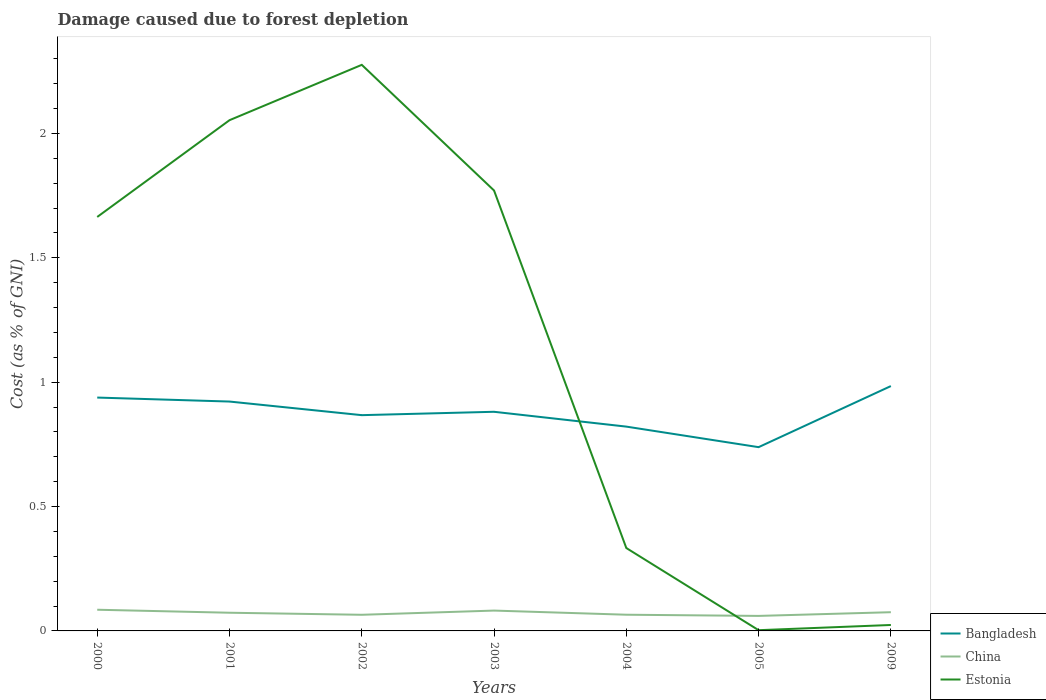How many different coloured lines are there?
Give a very brief answer. 3. Across all years, what is the maximum cost of damage caused due to forest depletion in China?
Offer a terse response. 0.06. In which year was the cost of damage caused due to forest depletion in China maximum?
Your answer should be very brief. 2005. What is the total cost of damage caused due to forest depletion in Bangladesh in the graph?
Provide a short and direct response. 0.18. What is the difference between the highest and the second highest cost of damage caused due to forest depletion in Bangladesh?
Keep it short and to the point. 0.25. Is the cost of damage caused due to forest depletion in China strictly greater than the cost of damage caused due to forest depletion in Estonia over the years?
Keep it short and to the point. No. How many years are there in the graph?
Offer a terse response. 7. What is the difference between two consecutive major ticks on the Y-axis?
Offer a very short reply. 0.5. Are the values on the major ticks of Y-axis written in scientific E-notation?
Give a very brief answer. No. How are the legend labels stacked?
Your answer should be compact. Vertical. What is the title of the graph?
Your answer should be very brief. Damage caused due to forest depletion. Does "South Africa" appear as one of the legend labels in the graph?
Offer a very short reply. No. What is the label or title of the Y-axis?
Provide a succinct answer. Cost (as % of GNI). What is the Cost (as % of GNI) of Bangladesh in 2000?
Provide a short and direct response. 0.94. What is the Cost (as % of GNI) in China in 2000?
Your response must be concise. 0.09. What is the Cost (as % of GNI) of Estonia in 2000?
Your answer should be compact. 1.66. What is the Cost (as % of GNI) of Bangladesh in 2001?
Provide a succinct answer. 0.92. What is the Cost (as % of GNI) in China in 2001?
Keep it short and to the point. 0.07. What is the Cost (as % of GNI) in Estonia in 2001?
Your answer should be very brief. 2.05. What is the Cost (as % of GNI) of Bangladesh in 2002?
Keep it short and to the point. 0.87. What is the Cost (as % of GNI) in China in 2002?
Keep it short and to the point. 0.06. What is the Cost (as % of GNI) in Estonia in 2002?
Provide a succinct answer. 2.28. What is the Cost (as % of GNI) of Bangladesh in 2003?
Keep it short and to the point. 0.88. What is the Cost (as % of GNI) of China in 2003?
Offer a very short reply. 0.08. What is the Cost (as % of GNI) of Estonia in 2003?
Make the answer very short. 1.77. What is the Cost (as % of GNI) of Bangladesh in 2004?
Your response must be concise. 0.82. What is the Cost (as % of GNI) of China in 2004?
Your answer should be compact. 0.07. What is the Cost (as % of GNI) of Estonia in 2004?
Ensure brevity in your answer.  0.33. What is the Cost (as % of GNI) in Bangladesh in 2005?
Offer a terse response. 0.74. What is the Cost (as % of GNI) of China in 2005?
Offer a terse response. 0.06. What is the Cost (as % of GNI) in Estonia in 2005?
Your response must be concise. 0. What is the Cost (as % of GNI) of Bangladesh in 2009?
Your response must be concise. 0.98. What is the Cost (as % of GNI) of China in 2009?
Your answer should be very brief. 0.08. What is the Cost (as % of GNI) of Estonia in 2009?
Provide a succinct answer. 0.02. Across all years, what is the maximum Cost (as % of GNI) of Bangladesh?
Give a very brief answer. 0.98. Across all years, what is the maximum Cost (as % of GNI) of China?
Provide a succinct answer. 0.09. Across all years, what is the maximum Cost (as % of GNI) in Estonia?
Keep it short and to the point. 2.28. Across all years, what is the minimum Cost (as % of GNI) in Bangladesh?
Offer a terse response. 0.74. Across all years, what is the minimum Cost (as % of GNI) in China?
Keep it short and to the point. 0.06. Across all years, what is the minimum Cost (as % of GNI) in Estonia?
Your answer should be very brief. 0. What is the total Cost (as % of GNI) of Bangladesh in the graph?
Offer a very short reply. 6.15. What is the total Cost (as % of GNI) of China in the graph?
Your answer should be very brief. 0.51. What is the total Cost (as % of GNI) of Estonia in the graph?
Keep it short and to the point. 8.12. What is the difference between the Cost (as % of GNI) in Bangladesh in 2000 and that in 2001?
Keep it short and to the point. 0.02. What is the difference between the Cost (as % of GNI) in China in 2000 and that in 2001?
Ensure brevity in your answer.  0.01. What is the difference between the Cost (as % of GNI) of Estonia in 2000 and that in 2001?
Offer a terse response. -0.39. What is the difference between the Cost (as % of GNI) in Bangladesh in 2000 and that in 2002?
Give a very brief answer. 0.07. What is the difference between the Cost (as % of GNI) of China in 2000 and that in 2002?
Provide a short and direct response. 0.02. What is the difference between the Cost (as % of GNI) in Estonia in 2000 and that in 2002?
Offer a very short reply. -0.61. What is the difference between the Cost (as % of GNI) in Bangladesh in 2000 and that in 2003?
Give a very brief answer. 0.06. What is the difference between the Cost (as % of GNI) in China in 2000 and that in 2003?
Give a very brief answer. 0. What is the difference between the Cost (as % of GNI) of Estonia in 2000 and that in 2003?
Make the answer very short. -0.11. What is the difference between the Cost (as % of GNI) in Bangladesh in 2000 and that in 2004?
Give a very brief answer. 0.12. What is the difference between the Cost (as % of GNI) in China in 2000 and that in 2004?
Make the answer very short. 0.02. What is the difference between the Cost (as % of GNI) in Estonia in 2000 and that in 2004?
Your answer should be very brief. 1.33. What is the difference between the Cost (as % of GNI) of Bangladesh in 2000 and that in 2005?
Keep it short and to the point. 0.2. What is the difference between the Cost (as % of GNI) of China in 2000 and that in 2005?
Keep it short and to the point. 0.02. What is the difference between the Cost (as % of GNI) of Estonia in 2000 and that in 2005?
Your response must be concise. 1.66. What is the difference between the Cost (as % of GNI) in Bangladesh in 2000 and that in 2009?
Your response must be concise. -0.05. What is the difference between the Cost (as % of GNI) of China in 2000 and that in 2009?
Give a very brief answer. 0.01. What is the difference between the Cost (as % of GNI) in Estonia in 2000 and that in 2009?
Offer a very short reply. 1.64. What is the difference between the Cost (as % of GNI) of Bangladesh in 2001 and that in 2002?
Make the answer very short. 0.05. What is the difference between the Cost (as % of GNI) in China in 2001 and that in 2002?
Provide a succinct answer. 0.01. What is the difference between the Cost (as % of GNI) of Estonia in 2001 and that in 2002?
Provide a short and direct response. -0.22. What is the difference between the Cost (as % of GNI) of Bangladesh in 2001 and that in 2003?
Keep it short and to the point. 0.04. What is the difference between the Cost (as % of GNI) of China in 2001 and that in 2003?
Make the answer very short. -0.01. What is the difference between the Cost (as % of GNI) in Estonia in 2001 and that in 2003?
Your answer should be very brief. 0.28. What is the difference between the Cost (as % of GNI) in Bangladesh in 2001 and that in 2004?
Provide a succinct answer. 0.1. What is the difference between the Cost (as % of GNI) in China in 2001 and that in 2004?
Your response must be concise. 0.01. What is the difference between the Cost (as % of GNI) of Estonia in 2001 and that in 2004?
Provide a short and direct response. 1.72. What is the difference between the Cost (as % of GNI) in Bangladesh in 2001 and that in 2005?
Keep it short and to the point. 0.18. What is the difference between the Cost (as % of GNI) in China in 2001 and that in 2005?
Give a very brief answer. 0.01. What is the difference between the Cost (as % of GNI) in Estonia in 2001 and that in 2005?
Your answer should be very brief. 2.05. What is the difference between the Cost (as % of GNI) in Bangladesh in 2001 and that in 2009?
Offer a terse response. -0.06. What is the difference between the Cost (as % of GNI) of China in 2001 and that in 2009?
Keep it short and to the point. -0. What is the difference between the Cost (as % of GNI) of Estonia in 2001 and that in 2009?
Keep it short and to the point. 2.03. What is the difference between the Cost (as % of GNI) of Bangladesh in 2002 and that in 2003?
Offer a very short reply. -0.01. What is the difference between the Cost (as % of GNI) in China in 2002 and that in 2003?
Your response must be concise. -0.02. What is the difference between the Cost (as % of GNI) of Estonia in 2002 and that in 2003?
Provide a short and direct response. 0.51. What is the difference between the Cost (as % of GNI) in Bangladesh in 2002 and that in 2004?
Your answer should be very brief. 0.05. What is the difference between the Cost (as % of GNI) in China in 2002 and that in 2004?
Your response must be concise. -0. What is the difference between the Cost (as % of GNI) of Estonia in 2002 and that in 2004?
Offer a very short reply. 1.94. What is the difference between the Cost (as % of GNI) in Bangladesh in 2002 and that in 2005?
Your answer should be compact. 0.13. What is the difference between the Cost (as % of GNI) of China in 2002 and that in 2005?
Give a very brief answer. 0. What is the difference between the Cost (as % of GNI) in Estonia in 2002 and that in 2005?
Give a very brief answer. 2.27. What is the difference between the Cost (as % of GNI) in Bangladesh in 2002 and that in 2009?
Make the answer very short. -0.12. What is the difference between the Cost (as % of GNI) in China in 2002 and that in 2009?
Ensure brevity in your answer.  -0.01. What is the difference between the Cost (as % of GNI) of Estonia in 2002 and that in 2009?
Provide a succinct answer. 2.25. What is the difference between the Cost (as % of GNI) of Bangladesh in 2003 and that in 2004?
Provide a succinct answer. 0.06. What is the difference between the Cost (as % of GNI) in China in 2003 and that in 2004?
Your response must be concise. 0.02. What is the difference between the Cost (as % of GNI) in Estonia in 2003 and that in 2004?
Your answer should be compact. 1.44. What is the difference between the Cost (as % of GNI) of Bangladesh in 2003 and that in 2005?
Your answer should be compact. 0.14. What is the difference between the Cost (as % of GNI) of China in 2003 and that in 2005?
Ensure brevity in your answer.  0.02. What is the difference between the Cost (as % of GNI) in Estonia in 2003 and that in 2005?
Keep it short and to the point. 1.77. What is the difference between the Cost (as % of GNI) of Bangladesh in 2003 and that in 2009?
Your response must be concise. -0.1. What is the difference between the Cost (as % of GNI) in China in 2003 and that in 2009?
Your answer should be compact. 0.01. What is the difference between the Cost (as % of GNI) in Estonia in 2003 and that in 2009?
Provide a short and direct response. 1.75. What is the difference between the Cost (as % of GNI) of Bangladesh in 2004 and that in 2005?
Your answer should be compact. 0.08. What is the difference between the Cost (as % of GNI) in China in 2004 and that in 2005?
Your answer should be compact. 0. What is the difference between the Cost (as % of GNI) of Estonia in 2004 and that in 2005?
Your answer should be compact. 0.33. What is the difference between the Cost (as % of GNI) of Bangladesh in 2004 and that in 2009?
Your answer should be very brief. -0.16. What is the difference between the Cost (as % of GNI) in China in 2004 and that in 2009?
Offer a very short reply. -0.01. What is the difference between the Cost (as % of GNI) in Estonia in 2004 and that in 2009?
Give a very brief answer. 0.31. What is the difference between the Cost (as % of GNI) in Bangladesh in 2005 and that in 2009?
Your response must be concise. -0.25. What is the difference between the Cost (as % of GNI) of China in 2005 and that in 2009?
Provide a succinct answer. -0.01. What is the difference between the Cost (as % of GNI) of Estonia in 2005 and that in 2009?
Provide a short and direct response. -0.02. What is the difference between the Cost (as % of GNI) in Bangladesh in 2000 and the Cost (as % of GNI) in China in 2001?
Make the answer very short. 0.87. What is the difference between the Cost (as % of GNI) of Bangladesh in 2000 and the Cost (as % of GNI) of Estonia in 2001?
Your answer should be compact. -1.12. What is the difference between the Cost (as % of GNI) of China in 2000 and the Cost (as % of GNI) of Estonia in 2001?
Make the answer very short. -1.97. What is the difference between the Cost (as % of GNI) in Bangladesh in 2000 and the Cost (as % of GNI) in China in 2002?
Give a very brief answer. 0.87. What is the difference between the Cost (as % of GNI) of Bangladesh in 2000 and the Cost (as % of GNI) of Estonia in 2002?
Your answer should be compact. -1.34. What is the difference between the Cost (as % of GNI) in China in 2000 and the Cost (as % of GNI) in Estonia in 2002?
Make the answer very short. -2.19. What is the difference between the Cost (as % of GNI) of Bangladesh in 2000 and the Cost (as % of GNI) of China in 2003?
Offer a very short reply. 0.86. What is the difference between the Cost (as % of GNI) of Bangladesh in 2000 and the Cost (as % of GNI) of Estonia in 2003?
Your answer should be compact. -0.83. What is the difference between the Cost (as % of GNI) in China in 2000 and the Cost (as % of GNI) in Estonia in 2003?
Offer a terse response. -1.69. What is the difference between the Cost (as % of GNI) of Bangladesh in 2000 and the Cost (as % of GNI) of China in 2004?
Provide a succinct answer. 0.87. What is the difference between the Cost (as % of GNI) of Bangladesh in 2000 and the Cost (as % of GNI) of Estonia in 2004?
Ensure brevity in your answer.  0.6. What is the difference between the Cost (as % of GNI) of China in 2000 and the Cost (as % of GNI) of Estonia in 2004?
Provide a short and direct response. -0.25. What is the difference between the Cost (as % of GNI) of Bangladesh in 2000 and the Cost (as % of GNI) of China in 2005?
Your answer should be compact. 0.88. What is the difference between the Cost (as % of GNI) of Bangladesh in 2000 and the Cost (as % of GNI) of Estonia in 2005?
Your response must be concise. 0.94. What is the difference between the Cost (as % of GNI) in China in 2000 and the Cost (as % of GNI) in Estonia in 2005?
Provide a succinct answer. 0.08. What is the difference between the Cost (as % of GNI) of Bangladesh in 2000 and the Cost (as % of GNI) of China in 2009?
Your response must be concise. 0.86. What is the difference between the Cost (as % of GNI) of Bangladesh in 2000 and the Cost (as % of GNI) of Estonia in 2009?
Your answer should be compact. 0.91. What is the difference between the Cost (as % of GNI) of China in 2000 and the Cost (as % of GNI) of Estonia in 2009?
Provide a short and direct response. 0.06. What is the difference between the Cost (as % of GNI) in Bangladesh in 2001 and the Cost (as % of GNI) in China in 2002?
Keep it short and to the point. 0.86. What is the difference between the Cost (as % of GNI) of Bangladesh in 2001 and the Cost (as % of GNI) of Estonia in 2002?
Provide a short and direct response. -1.35. What is the difference between the Cost (as % of GNI) in China in 2001 and the Cost (as % of GNI) in Estonia in 2002?
Keep it short and to the point. -2.2. What is the difference between the Cost (as % of GNI) of Bangladesh in 2001 and the Cost (as % of GNI) of China in 2003?
Ensure brevity in your answer.  0.84. What is the difference between the Cost (as % of GNI) in Bangladesh in 2001 and the Cost (as % of GNI) in Estonia in 2003?
Offer a very short reply. -0.85. What is the difference between the Cost (as % of GNI) of China in 2001 and the Cost (as % of GNI) of Estonia in 2003?
Provide a succinct answer. -1.7. What is the difference between the Cost (as % of GNI) in Bangladesh in 2001 and the Cost (as % of GNI) in China in 2004?
Your answer should be compact. 0.86. What is the difference between the Cost (as % of GNI) in Bangladesh in 2001 and the Cost (as % of GNI) in Estonia in 2004?
Ensure brevity in your answer.  0.59. What is the difference between the Cost (as % of GNI) of China in 2001 and the Cost (as % of GNI) of Estonia in 2004?
Offer a very short reply. -0.26. What is the difference between the Cost (as % of GNI) in Bangladesh in 2001 and the Cost (as % of GNI) in China in 2005?
Give a very brief answer. 0.86. What is the difference between the Cost (as % of GNI) in Bangladesh in 2001 and the Cost (as % of GNI) in Estonia in 2005?
Your response must be concise. 0.92. What is the difference between the Cost (as % of GNI) in China in 2001 and the Cost (as % of GNI) in Estonia in 2005?
Provide a succinct answer. 0.07. What is the difference between the Cost (as % of GNI) in Bangladesh in 2001 and the Cost (as % of GNI) in China in 2009?
Your answer should be very brief. 0.85. What is the difference between the Cost (as % of GNI) of Bangladesh in 2001 and the Cost (as % of GNI) of Estonia in 2009?
Provide a short and direct response. 0.9. What is the difference between the Cost (as % of GNI) of China in 2001 and the Cost (as % of GNI) of Estonia in 2009?
Your response must be concise. 0.05. What is the difference between the Cost (as % of GNI) in Bangladesh in 2002 and the Cost (as % of GNI) in China in 2003?
Your answer should be very brief. 0.79. What is the difference between the Cost (as % of GNI) in Bangladesh in 2002 and the Cost (as % of GNI) in Estonia in 2003?
Provide a succinct answer. -0.9. What is the difference between the Cost (as % of GNI) of China in 2002 and the Cost (as % of GNI) of Estonia in 2003?
Offer a very short reply. -1.71. What is the difference between the Cost (as % of GNI) of Bangladesh in 2002 and the Cost (as % of GNI) of China in 2004?
Offer a terse response. 0.8. What is the difference between the Cost (as % of GNI) of Bangladesh in 2002 and the Cost (as % of GNI) of Estonia in 2004?
Provide a succinct answer. 0.53. What is the difference between the Cost (as % of GNI) of China in 2002 and the Cost (as % of GNI) of Estonia in 2004?
Your answer should be very brief. -0.27. What is the difference between the Cost (as % of GNI) of Bangladesh in 2002 and the Cost (as % of GNI) of China in 2005?
Make the answer very short. 0.81. What is the difference between the Cost (as % of GNI) in Bangladesh in 2002 and the Cost (as % of GNI) in Estonia in 2005?
Offer a very short reply. 0.86. What is the difference between the Cost (as % of GNI) in China in 2002 and the Cost (as % of GNI) in Estonia in 2005?
Provide a short and direct response. 0.06. What is the difference between the Cost (as % of GNI) of Bangladesh in 2002 and the Cost (as % of GNI) of China in 2009?
Keep it short and to the point. 0.79. What is the difference between the Cost (as % of GNI) of Bangladesh in 2002 and the Cost (as % of GNI) of Estonia in 2009?
Give a very brief answer. 0.84. What is the difference between the Cost (as % of GNI) of China in 2002 and the Cost (as % of GNI) of Estonia in 2009?
Offer a very short reply. 0.04. What is the difference between the Cost (as % of GNI) of Bangladesh in 2003 and the Cost (as % of GNI) of China in 2004?
Provide a succinct answer. 0.82. What is the difference between the Cost (as % of GNI) of Bangladesh in 2003 and the Cost (as % of GNI) of Estonia in 2004?
Ensure brevity in your answer.  0.55. What is the difference between the Cost (as % of GNI) in China in 2003 and the Cost (as % of GNI) in Estonia in 2004?
Offer a very short reply. -0.25. What is the difference between the Cost (as % of GNI) in Bangladesh in 2003 and the Cost (as % of GNI) in China in 2005?
Your answer should be very brief. 0.82. What is the difference between the Cost (as % of GNI) of Bangladesh in 2003 and the Cost (as % of GNI) of Estonia in 2005?
Keep it short and to the point. 0.88. What is the difference between the Cost (as % of GNI) of China in 2003 and the Cost (as % of GNI) of Estonia in 2005?
Give a very brief answer. 0.08. What is the difference between the Cost (as % of GNI) of Bangladesh in 2003 and the Cost (as % of GNI) of China in 2009?
Ensure brevity in your answer.  0.81. What is the difference between the Cost (as % of GNI) in Bangladesh in 2003 and the Cost (as % of GNI) in Estonia in 2009?
Your answer should be very brief. 0.86. What is the difference between the Cost (as % of GNI) in China in 2003 and the Cost (as % of GNI) in Estonia in 2009?
Make the answer very short. 0.06. What is the difference between the Cost (as % of GNI) of Bangladesh in 2004 and the Cost (as % of GNI) of China in 2005?
Provide a short and direct response. 0.76. What is the difference between the Cost (as % of GNI) in Bangladesh in 2004 and the Cost (as % of GNI) in Estonia in 2005?
Offer a very short reply. 0.82. What is the difference between the Cost (as % of GNI) of China in 2004 and the Cost (as % of GNI) of Estonia in 2005?
Your answer should be very brief. 0.06. What is the difference between the Cost (as % of GNI) in Bangladesh in 2004 and the Cost (as % of GNI) in China in 2009?
Keep it short and to the point. 0.75. What is the difference between the Cost (as % of GNI) in Bangladesh in 2004 and the Cost (as % of GNI) in Estonia in 2009?
Your answer should be very brief. 0.8. What is the difference between the Cost (as % of GNI) of China in 2004 and the Cost (as % of GNI) of Estonia in 2009?
Keep it short and to the point. 0.04. What is the difference between the Cost (as % of GNI) in Bangladesh in 2005 and the Cost (as % of GNI) in China in 2009?
Keep it short and to the point. 0.66. What is the difference between the Cost (as % of GNI) in Bangladesh in 2005 and the Cost (as % of GNI) in Estonia in 2009?
Make the answer very short. 0.71. What is the difference between the Cost (as % of GNI) of China in 2005 and the Cost (as % of GNI) of Estonia in 2009?
Provide a succinct answer. 0.04. What is the average Cost (as % of GNI) of Bangladesh per year?
Your response must be concise. 0.88. What is the average Cost (as % of GNI) of China per year?
Ensure brevity in your answer.  0.07. What is the average Cost (as % of GNI) of Estonia per year?
Give a very brief answer. 1.16. In the year 2000, what is the difference between the Cost (as % of GNI) in Bangladesh and Cost (as % of GNI) in China?
Offer a terse response. 0.85. In the year 2000, what is the difference between the Cost (as % of GNI) in Bangladesh and Cost (as % of GNI) in Estonia?
Offer a very short reply. -0.73. In the year 2000, what is the difference between the Cost (as % of GNI) of China and Cost (as % of GNI) of Estonia?
Make the answer very short. -1.58. In the year 2001, what is the difference between the Cost (as % of GNI) of Bangladesh and Cost (as % of GNI) of China?
Ensure brevity in your answer.  0.85. In the year 2001, what is the difference between the Cost (as % of GNI) in Bangladesh and Cost (as % of GNI) in Estonia?
Give a very brief answer. -1.13. In the year 2001, what is the difference between the Cost (as % of GNI) of China and Cost (as % of GNI) of Estonia?
Give a very brief answer. -1.98. In the year 2002, what is the difference between the Cost (as % of GNI) of Bangladesh and Cost (as % of GNI) of China?
Your response must be concise. 0.8. In the year 2002, what is the difference between the Cost (as % of GNI) in Bangladesh and Cost (as % of GNI) in Estonia?
Your answer should be very brief. -1.41. In the year 2002, what is the difference between the Cost (as % of GNI) of China and Cost (as % of GNI) of Estonia?
Your answer should be very brief. -2.21. In the year 2003, what is the difference between the Cost (as % of GNI) in Bangladesh and Cost (as % of GNI) in China?
Your answer should be very brief. 0.8. In the year 2003, what is the difference between the Cost (as % of GNI) in Bangladesh and Cost (as % of GNI) in Estonia?
Provide a short and direct response. -0.89. In the year 2003, what is the difference between the Cost (as % of GNI) of China and Cost (as % of GNI) of Estonia?
Your answer should be very brief. -1.69. In the year 2004, what is the difference between the Cost (as % of GNI) of Bangladesh and Cost (as % of GNI) of China?
Offer a terse response. 0.76. In the year 2004, what is the difference between the Cost (as % of GNI) of Bangladesh and Cost (as % of GNI) of Estonia?
Your answer should be compact. 0.49. In the year 2004, what is the difference between the Cost (as % of GNI) of China and Cost (as % of GNI) of Estonia?
Provide a succinct answer. -0.27. In the year 2005, what is the difference between the Cost (as % of GNI) of Bangladesh and Cost (as % of GNI) of China?
Provide a short and direct response. 0.68. In the year 2005, what is the difference between the Cost (as % of GNI) in Bangladesh and Cost (as % of GNI) in Estonia?
Keep it short and to the point. 0.74. In the year 2005, what is the difference between the Cost (as % of GNI) of China and Cost (as % of GNI) of Estonia?
Keep it short and to the point. 0.06. In the year 2009, what is the difference between the Cost (as % of GNI) of Bangladesh and Cost (as % of GNI) of China?
Make the answer very short. 0.91. In the year 2009, what is the difference between the Cost (as % of GNI) of Bangladesh and Cost (as % of GNI) of Estonia?
Make the answer very short. 0.96. In the year 2009, what is the difference between the Cost (as % of GNI) of China and Cost (as % of GNI) of Estonia?
Offer a very short reply. 0.05. What is the ratio of the Cost (as % of GNI) in Bangladesh in 2000 to that in 2001?
Make the answer very short. 1.02. What is the ratio of the Cost (as % of GNI) of China in 2000 to that in 2001?
Your answer should be very brief. 1.17. What is the ratio of the Cost (as % of GNI) of Estonia in 2000 to that in 2001?
Provide a short and direct response. 0.81. What is the ratio of the Cost (as % of GNI) of Bangladesh in 2000 to that in 2002?
Provide a short and direct response. 1.08. What is the ratio of the Cost (as % of GNI) of China in 2000 to that in 2002?
Offer a terse response. 1.31. What is the ratio of the Cost (as % of GNI) in Estonia in 2000 to that in 2002?
Provide a short and direct response. 0.73. What is the ratio of the Cost (as % of GNI) of Bangladesh in 2000 to that in 2003?
Your answer should be compact. 1.06. What is the ratio of the Cost (as % of GNI) of China in 2000 to that in 2003?
Give a very brief answer. 1.04. What is the ratio of the Cost (as % of GNI) of Estonia in 2000 to that in 2003?
Give a very brief answer. 0.94. What is the ratio of the Cost (as % of GNI) in Bangladesh in 2000 to that in 2004?
Offer a terse response. 1.14. What is the ratio of the Cost (as % of GNI) of China in 2000 to that in 2004?
Give a very brief answer. 1.31. What is the ratio of the Cost (as % of GNI) of Estonia in 2000 to that in 2004?
Offer a terse response. 4.99. What is the ratio of the Cost (as % of GNI) of Bangladesh in 2000 to that in 2005?
Provide a short and direct response. 1.27. What is the ratio of the Cost (as % of GNI) in China in 2000 to that in 2005?
Give a very brief answer. 1.41. What is the ratio of the Cost (as % of GNI) in Estonia in 2000 to that in 2005?
Your response must be concise. 559.5. What is the ratio of the Cost (as % of GNI) in Bangladesh in 2000 to that in 2009?
Offer a very short reply. 0.95. What is the ratio of the Cost (as % of GNI) in China in 2000 to that in 2009?
Offer a terse response. 1.13. What is the ratio of the Cost (as % of GNI) in Estonia in 2000 to that in 2009?
Your answer should be very brief. 69.63. What is the ratio of the Cost (as % of GNI) in Bangladesh in 2001 to that in 2002?
Give a very brief answer. 1.06. What is the ratio of the Cost (as % of GNI) of China in 2001 to that in 2002?
Provide a short and direct response. 1.13. What is the ratio of the Cost (as % of GNI) in Estonia in 2001 to that in 2002?
Offer a terse response. 0.9. What is the ratio of the Cost (as % of GNI) in Bangladesh in 2001 to that in 2003?
Offer a terse response. 1.05. What is the ratio of the Cost (as % of GNI) of China in 2001 to that in 2003?
Offer a terse response. 0.89. What is the ratio of the Cost (as % of GNI) of Estonia in 2001 to that in 2003?
Provide a short and direct response. 1.16. What is the ratio of the Cost (as % of GNI) of Bangladesh in 2001 to that in 2004?
Provide a succinct answer. 1.12. What is the ratio of the Cost (as % of GNI) of China in 2001 to that in 2004?
Provide a succinct answer. 1.12. What is the ratio of the Cost (as % of GNI) in Estonia in 2001 to that in 2004?
Make the answer very short. 6.16. What is the ratio of the Cost (as % of GNI) of Bangladesh in 2001 to that in 2005?
Make the answer very short. 1.25. What is the ratio of the Cost (as % of GNI) of China in 2001 to that in 2005?
Keep it short and to the point. 1.21. What is the ratio of the Cost (as % of GNI) of Estonia in 2001 to that in 2005?
Keep it short and to the point. 690.29. What is the ratio of the Cost (as % of GNI) in Bangladesh in 2001 to that in 2009?
Your answer should be very brief. 0.94. What is the ratio of the Cost (as % of GNI) in China in 2001 to that in 2009?
Make the answer very short. 0.97. What is the ratio of the Cost (as % of GNI) in Estonia in 2001 to that in 2009?
Your response must be concise. 85.91. What is the ratio of the Cost (as % of GNI) in Bangladesh in 2002 to that in 2003?
Your answer should be compact. 0.98. What is the ratio of the Cost (as % of GNI) of China in 2002 to that in 2003?
Your answer should be very brief. 0.79. What is the ratio of the Cost (as % of GNI) of Estonia in 2002 to that in 2003?
Provide a succinct answer. 1.29. What is the ratio of the Cost (as % of GNI) in Bangladesh in 2002 to that in 2004?
Your response must be concise. 1.06. What is the ratio of the Cost (as % of GNI) in China in 2002 to that in 2004?
Give a very brief answer. 1. What is the ratio of the Cost (as % of GNI) in Estonia in 2002 to that in 2004?
Offer a terse response. 6.83. What is the ratio of the Cost (as % of GNI) of Bangladesh in 2002 to that in 2005?
Provide a short and direct response. 1.17. What is the ratio of the Cost (as % of GNI) of China in 2002 to that in 2005?
Offer a terse response. 1.07. What is the ratio of the Cost (as % of GNI) in Estonia in 2002 to that in 2005?
Your response must be concise. 765.09. What is the ratio of the Cost (as % of GNI) of Bangladesh in 2002 to that in 2009?
Your answer should be compact. 0.88. What is the ratio of the Cost (as % of GNI) of China in 2002 to that in 2009?
Give a very brief answer. 0.86. What is the ratio of the Cost (as % of GNI) in Estonia in 2002 to that in 2009?
Your answer should be compact. 95.22. What is the ratio of the Cost (as % of GNI) in Bangladesh in 2003 to that in 2004?
Offer a very short reply. 1.07. What is the ratio of the Cost (as % of GNI) in China in 2003 to that in 2004?
Offer a very short reply. 1.26. What is the ratio of the Cost (as % of GNI) in Estonia in 2003 to that in 2004?
Your answer should be very brief. 5.31. What is the ratio of the Cost (as % of GNI) of Bangladesh in 2003 to that in 2005?
Ensure brevity in your answer.  1.19. What is the ratio of the Cost (as % of GNI) in China in 2003 to that in 2005?
Ensure brevity in your answer.  1.36. What is the ratio of the Cost (as % of GNI) in Estonia in 2003 to that in 2005?
Give a very brief answer. 595.25. What is the ratio of the Cost (as % of GNI) in Bangladesh in 2003 to that in 2009?
Your answer should be very brief. 0.9. What is the ratio of the Cost (as % of GNI) of China in 2003 to that in 2009?
Your answer should be very brief. 1.09. What is the ratio of the Cost (as % of GNI) of Estonia in 2003 to that in 2009?
Offer a terse response. 74.08. What is the ratio of the Cost (as % of GNI) in Bangladesh in 2004 to that in 2005?
Provide a succinct answer. 1.11. What is the ratio of the Cost (as % of GNI) in China in 2004 to that in 2005?
Your response must be concise. 1.08. What is the ratio of the Cost (as % of GNI) of Estonia in 2004 to that in 2005?
Ensure brevity in your answer.  112.03. What is the ratio of the Cost (as % of GNI) of Bangladesh in 2004 to that in 2009?
Offer a very short reply. 0.83. What is the ratio of the Cost (as % of GNI) of China in 2004 to that in 2009?
Offer a terse response. 0.87. What is the ratio of the Cost (as % of GNI) in Estonia in 2004 to that in 2009?
Your answer should be very brief. 13.94. What is the ratio of the Cost (as % of GNI) of Bangladesh in 2005 to that in 2009?
Your answer should be very brief. 0.75. What is the ratio of the Cost (as % of GNI) of China in 2005 to that in 2009?
Ensure brevity in your answer.  0.8. What is the ratio of the Cost (as % of GNI) of Estonia in 2005 to that in 2009?
Ensure brevity in your answer.  0.12. What is the difference between the highest and the second highest Cost (as % of GNI) of Bangladesh?
Provide a short and direct response. 0.05. What is the difference between the highest and the second highest Cost (as % of GNI) of China?
Offer a very short reply. 0. What is the difference between the highest and the second highest Cost (as % of GNI) of Estonia?
Provide a succinct answer. 0.22. What is the difference between the highest and the lowest Cost (as % of GNI) in Bangladesh?
Provide a succinct answer. 0.25. What is the difference between the highest and the lowest Cost (as % of GNI) in China?
Your answer should be very brief. 0.02. What is the difference between the highest and the lowest Cost (as % of GNI) of Estonia?
Your answer should be very brief. 2.27. 